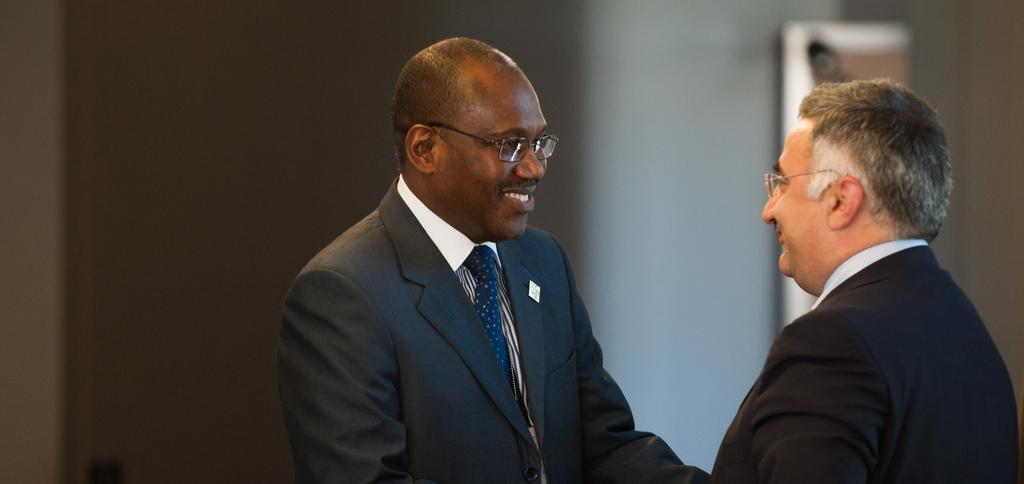How many people are in the image? There are two persons in the image. What are the people wearing on their faces? Both persons are wearing glasses. What type of clothing are the people wearing? Both persons are wearing suits. What expression do the people have in the image? Both persons are smiling. What can be seen in the background of the image? There is a wall and an object in the background of the image. What type of vegetable is being used as a quiver in the image? There is no vegetable or quiver present in the image. 